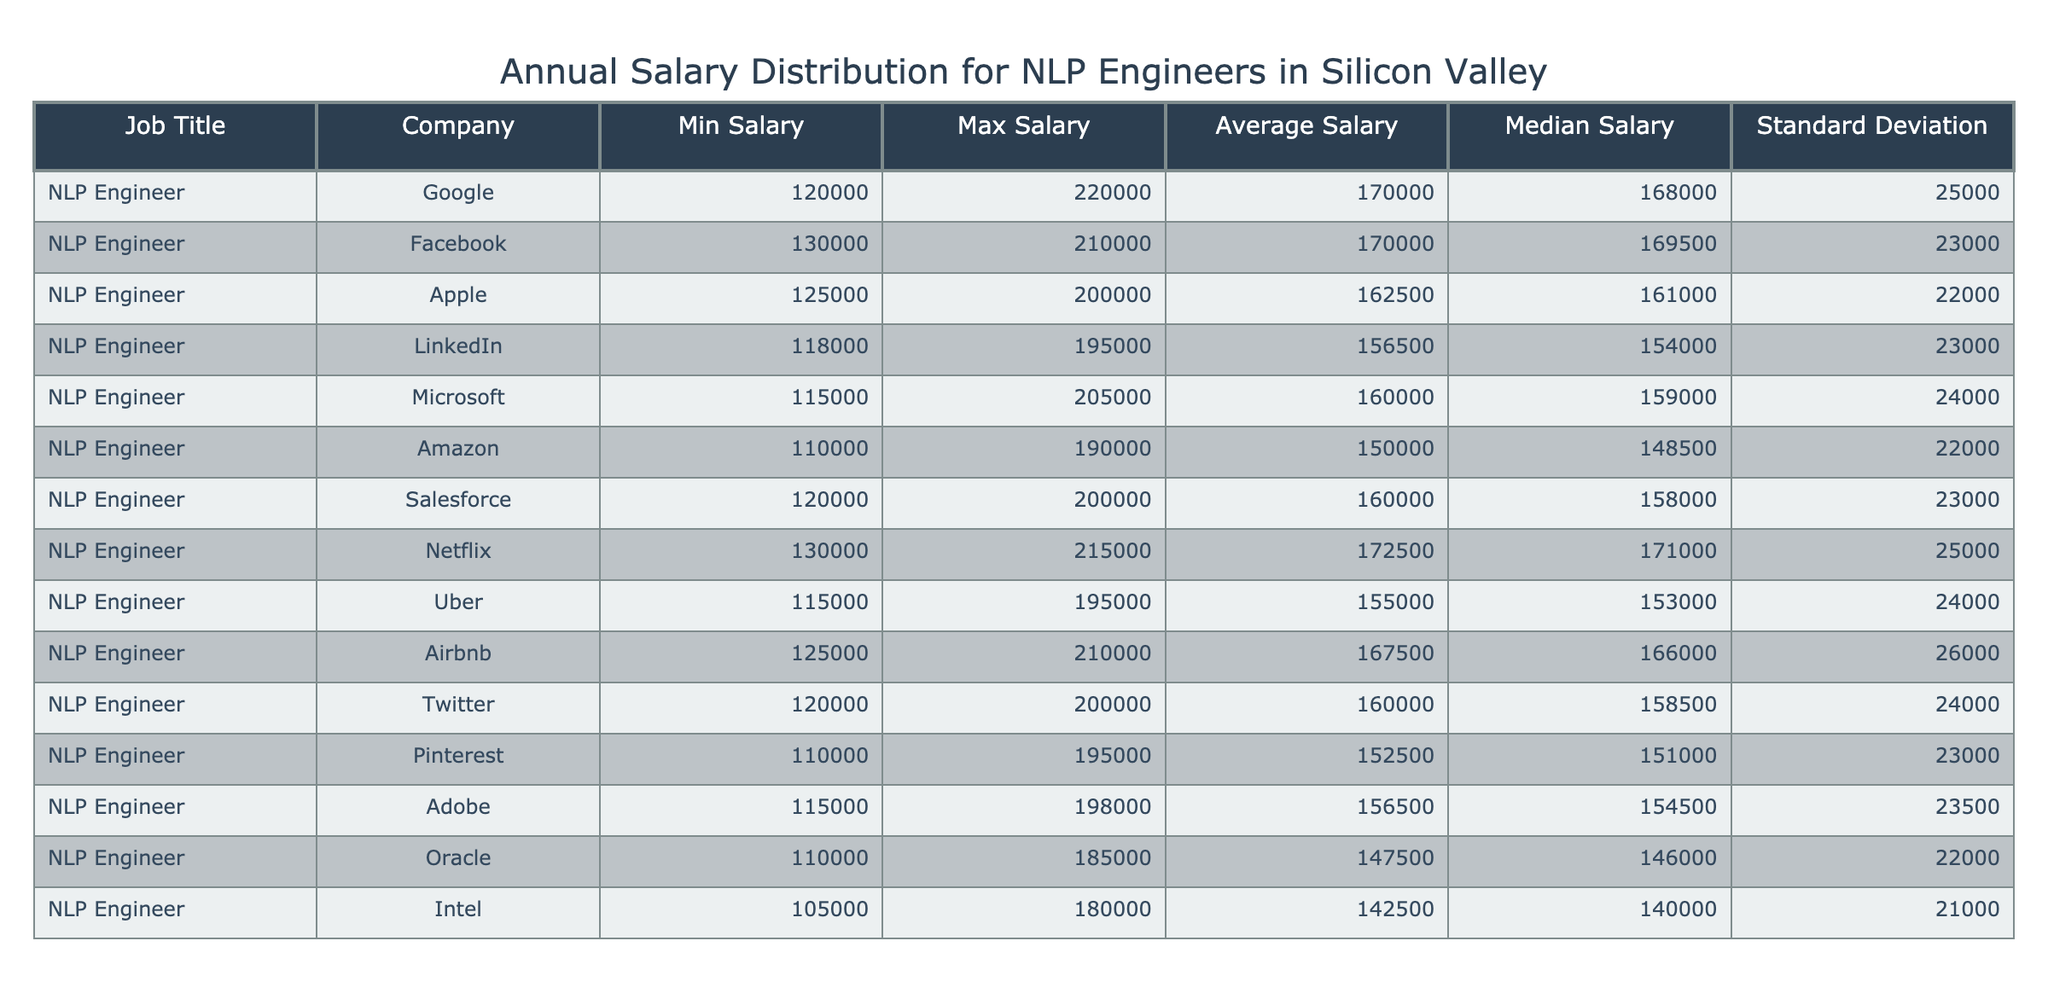What is the average salary for NLP Engineers at Google? According to the table, the average salary for NLP Engineers at Google is directly listed under the "Average Salary" column. The value is 170000.
Answer: 170000 Which company offers the highest maximum salary for NLP Engineers? The maximum salaries for each company are compared: Google (220000), Facebook (210000), Netflix (215000), and others. Google has the highest maximum salary of 220000.
Answer: Google What is the difference between the average and median salary for NLP Engineers at Amazon? In the table, Amazon has an average salary of 150000 and a median salary of 148500. The difference is calculated as 150000 - 148500 = 1500.
Answer: 1500 Is the average salary of NLP Engineers at LinkedIn higher than that at Microsoft? By checking both average salaries, LinkedIn has an average of 156500 while Microsoft has an average of 160000. Since 156500 is less than 160000, the statement is false.
Answer: No Which company has the lowest minimum salary for NLP Engineers? The minimum salaries are compared: Google (120000), Facebook (130000), Amazon (110000), and others. Amazon has the lowest minimum salary of 110000.
Answer: Amazon What is the total average salary for all companies listed in the table? To find the total average salary, I first need to sum all average salaries: (170000 + 170000 + 162500 + 156500 + 160000 + 150000 + 160000 + 172500 + 155000 + 167500 + 160000 + 152500 + 156500 + 147500 + 142500) = 2288500, then divide by the total number of companies (15): 2288500 / 15 = 152566.67. Therefore, the total average salary is approximately 152567.
Answer: 152567 Is the standard deviation of the average salary at Adobe greater than that at Apple? The standard deviation for Adobe is 23500 and for Apple, it is 22000. Since 23500 is greater than 22000, the statement is true.
Answer: Yes What is the average salary for the top three highest-paying companies for NLP Engineers? The three companies with the highest average salaries are: Google (170000), Facebook (170000), and Netflix (172500). The total is calculated as (170000 + 170000 + 172500) = 512500. To find the average, divide by 3: 512500 / 3 = 170833.33. Therefore, the average salary for the top three is approximately 170833.
Answer: 170833 How many companies listed have an average salary above 160000? By reviewing the average salaries, the companies with averages above 160000 are Google (170000), Facebook (170000), Netflix (172500), Microsoft (160000), Salesforce (160000), Airbnb (167500), and Twitter (160000). Counting these gives a total of 7 companies.
Answer: 7 